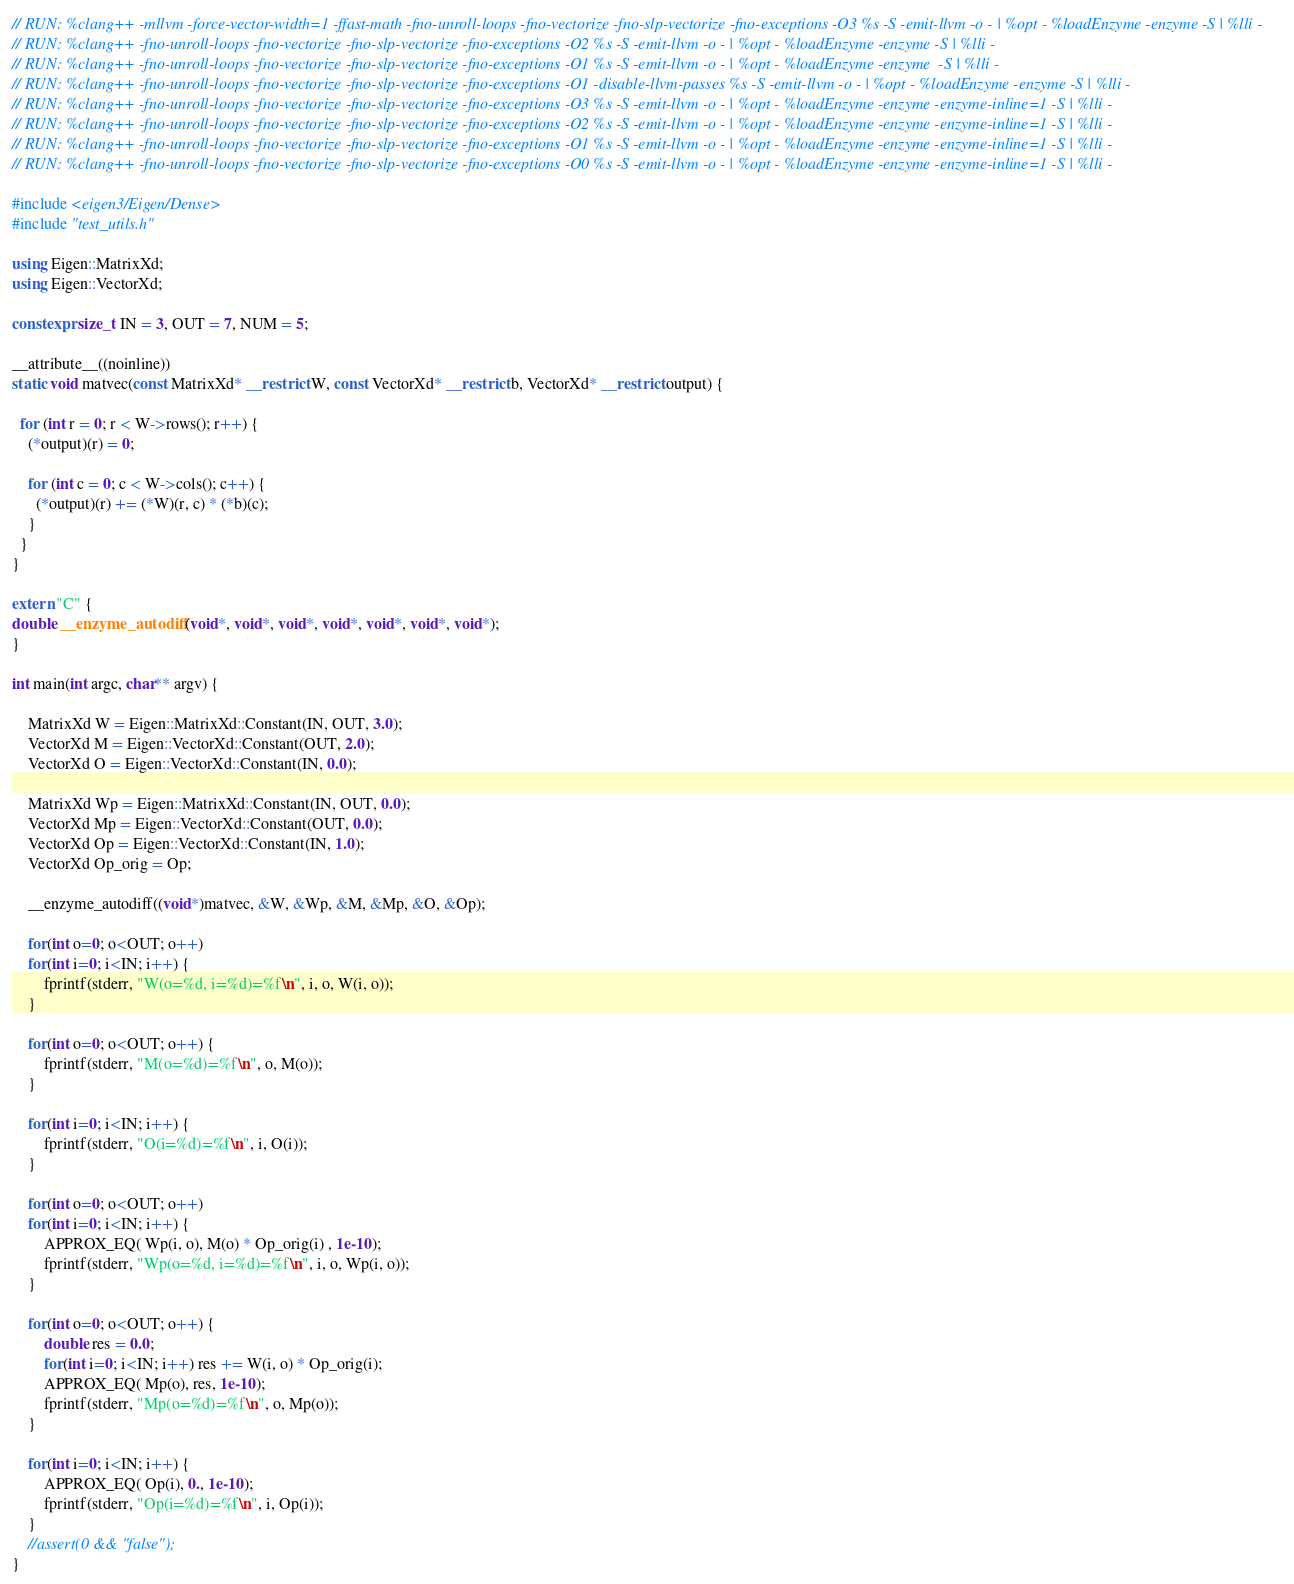<code> <loc_0><loc_0><loc_500><loc_500><_C++_>// RUN: %clang++ -mllvm -force-vector-width=1 -ffast-math -fno-unroll-loops -fno-vectorize -fno-slp-vectorize -fno-exceptions -O3 %s -S -emit-llvm -o - | %opt - %loadEnzyme -enzyme -S | %lli - 
// RUN: %clang++ -fno-unroll-loops -fno-vectorize -fno-slp-vectorize -fno-exceptions -O2 %s -S -emit-llvm -o - | %opt - %loadEnzyme -enzyme -S | %lli - 
// RUN: %clang++ -fno-unroll-loops -fno-vectorize -fno-slp-vectorize -fno-exceptions -O1 %s -S -emit-llvm -o - | %opt - %loadEnzyme -enzyme  -S | %lli - 
// RUN: %clang++ -fno-unroll-loops -fno-vectorize -fno-slp-vectorize -fno-exceptions -O1 -disable-llvm-passes %s -S -emit-llvm -o - | %opt - %loadEnzyme -enzyme -S | %lli - 
// RUN: %clang++ -fno-unroll-loops -fno-vectorize -fno-slp-vectorize -fno-exceptions -O3 %s -S -emit-llvm -o - | %opt - %loadEnzyme -enzyme -enzyme-inline=1 -S | %lli - 
// RUN: %clang++ -fno-unroll-loops -fno-vectorize -fno-slp-vectorize -fno-exceptions -O2 %s -S -emit-llvm -o - | %opt - %loadEnzyme -enzyme -enzyme-inline=1 -S | %lli - 
// RUN: %clang++ -fno-unroll-loops -fno-vectorize -fno-slp-vectorize -fno-exceptions -O1 %s -S -emit-llvm -o - | %opt - %loadEnzyme -enzyme -enzyme-inline=1 -S | %lli - 
// RUN: %clang++ -fno-unroll-loops -fno-vectorize -fno-slp-vectorize -fno-exceptions -O0 %s -S -emit-llvm -o - | %opt - %loadEnzyme -enzyme -enzyme-inline=1 -S | %lli - 

#include <eigen3/Eigen/Dense>
#include "test_utils.h"

using Eigen::MatrixXd;
using Eigen::VectorXd;

constexpr size_t IN = 3, OUT = 7, NUM = 5;

__attribute__((noinline))
static void matvec(const MatrixXd* __restrict W, const VectorXd* __restrict b, VectorXd* __restrict output) {

  for (int r = 0; r < W->rows(); r++) {
    (*output)(r) = 0;

    for (int c = 0; c < W->cols(); c++) {
      (*output)(r) += (*W)(r, c) * (*b)(c);
    }
  }
}

extern "C" {
double __enzyme_autodiff(void*, void*, void*, void*, void*, void*, void*);
}

int main(int argc, char** argv) {

    MatrixXd W = Eigen::MatrixXd::Constant(IN, OUT, 3.0);
    VectorXd M = Eigen::VectorXd::Constant(OUT, 2.0);
    VectorXd O = Eigen::VectorXd::Constant(IN, 0.0);
    
    MatrixXd Wp = Eigen::MatrixXd::Constant(IN, OUT, 0.0);
    VectorXd Mp = Eigen::VectorXd::Constant(OUT, 0.0);
    VectorXd Op = Eigen::VectorXd::Constant(IN, 1.0);
    VectorXd Op_orig = Op;
    
    __enzyme_autodiff((void*)matvec, &W, &Wp, &M, &Mp, &O, &Op);
    
    for(int o=0; o<OUT; o++)
    for(int i=0; i<IN; i++) {
        fprintf(stderr, "W(o=%d, i=%d)=%f\n", i, o, W(i, o));
    }
     
    for(int o=0; o<OUT; o++) {
        fprintf(stderr, "M(o=%d)=%f\n", o, M(o));
    }
    
    for(int i=0; i<IN; i++) {
        fprintf(stderr, "O(i=%d)=%f\n", i, O(i));
    }

    for(int o=0; o<OUT; o++)
    for(int i=0; i<IN; i++) {
        APPROX_EQ( Wp(i, o), M(o) * Op_orig(i) , 1e-10);
        fprintf(stderr, "Wp(o=%d, i=%d)=%f\n", i, o, Wp(i, o));
    }
     
    for(int o=0; o<OUT; o++) {
        double res = 0.0;
        for(int i=0; i<IN; i++) res += W(i, o) * Op_orig(i); 
        APPROX_EQ( Mp(o), res, 1e-10);
        fprintf(stderr, "Mp(o=%d)=%f\n", o, Mp(o));
    }
    
    for(int i=0; i<IN; i++) {
        APPROX_EQ( Op(i), 0., 1e-10);
        fprintf(stderr, "Op(i=%d)=%f\n", i, Op(i));
    }
    //assert(0 && "false");
}
</code> 